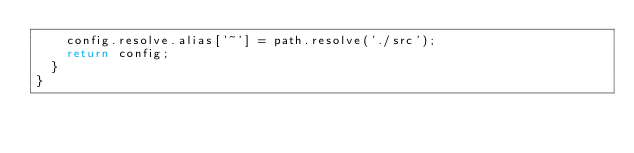Convert code to text. <code><loc_0><loc_0><loc_500><loc_500><_JavaScript_>    config.resolve.alias['~'] = path.resolve('./src');
    return config;
  }
}</code> 